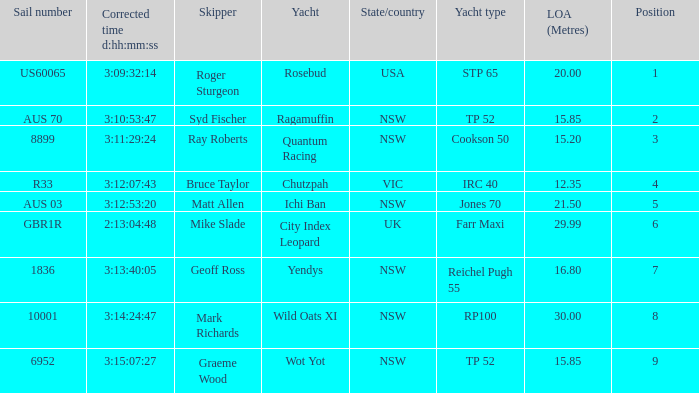What are all sail numbers for the yacht Yendys? 1836.0. 